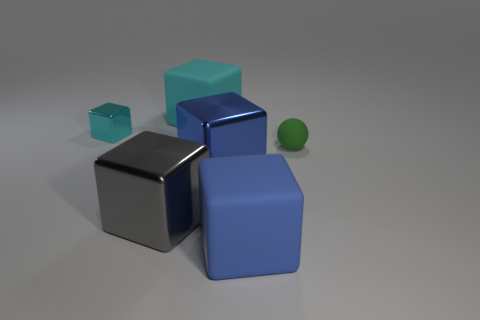How many rubber objects have the same shape as the tiny shiny object?
Make the answer very short. 2. What is the shape of the large blue metal object?
Keep it short and to the point. Cube. Are there an equal number of tiny rubber spheres that are in front of the small green matte ball and big purple rubber balls?
Offer a terse response. Yes. Is the big cube behind the tiny green sphere made of the same material as the small green ball?
Provide a succinct answer. Yes. Are there fewer small cyan metallic blocks that are in front of the blue metallic thing than blue matte things?
Ensure brevity in your answer.  Yes. What number of shiny things are either green things or blue objects?
Give a very brief answer. 1. Are there any other things that have the same color as the small cube?
Provide a succinct answer. Yes. There is a blue object that is to the left of the blue matte block; is its shape the same as the large thing that is behind the cyan shiny object?
Offer a terse response. Yes. What number of things are either green matte objects or blue cubes that are behind the blue matte thing?
Your response must be concise. 2. How many other objects are there of the same size as the rubber ball?
Keep it short and to the point. 1. 